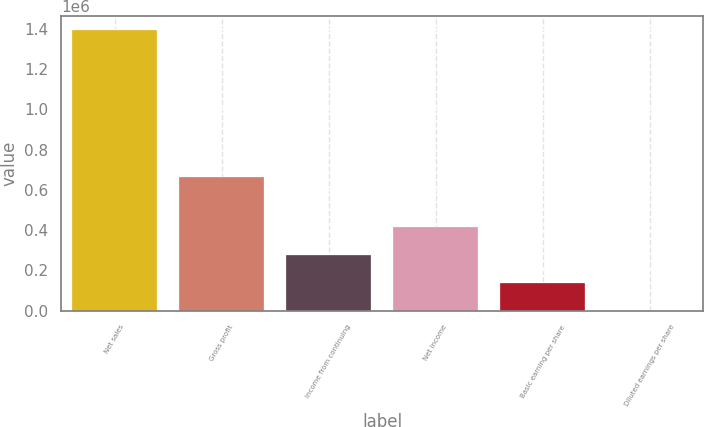Convert chart to OTSL. <chart><loc_0><loc_0><loc_500><loc_500><bar_chart><fcel>Net sales<fcel>Gross profit<fcel>Income from continuing<fcel>Net income<fcel>Basic earning per share<fcel>Diluted earnings per share<nl><fcel>1.39301e+06<fcel>665168<fcel>278603<fcel>417903<fcel>139302<fcel>0.68<nl></chart> 